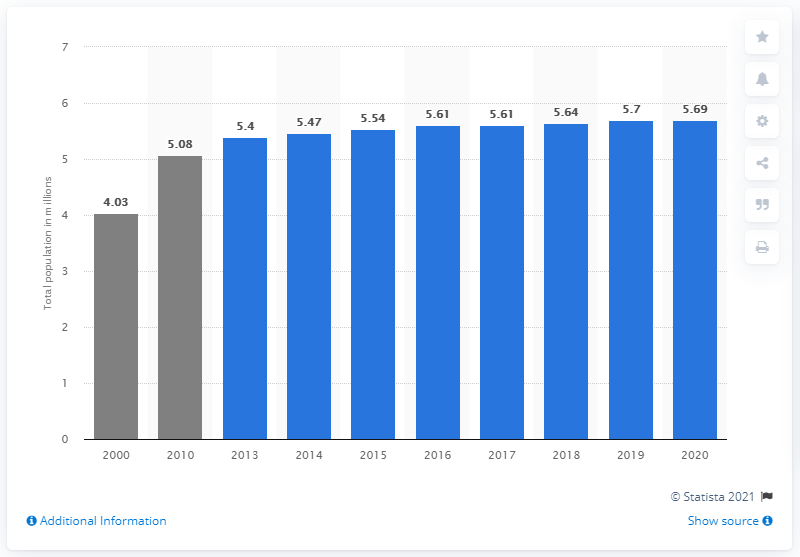List a handful of essential elements in this visual. In 2020, the population of Singapore was approximately 5.69 million. 